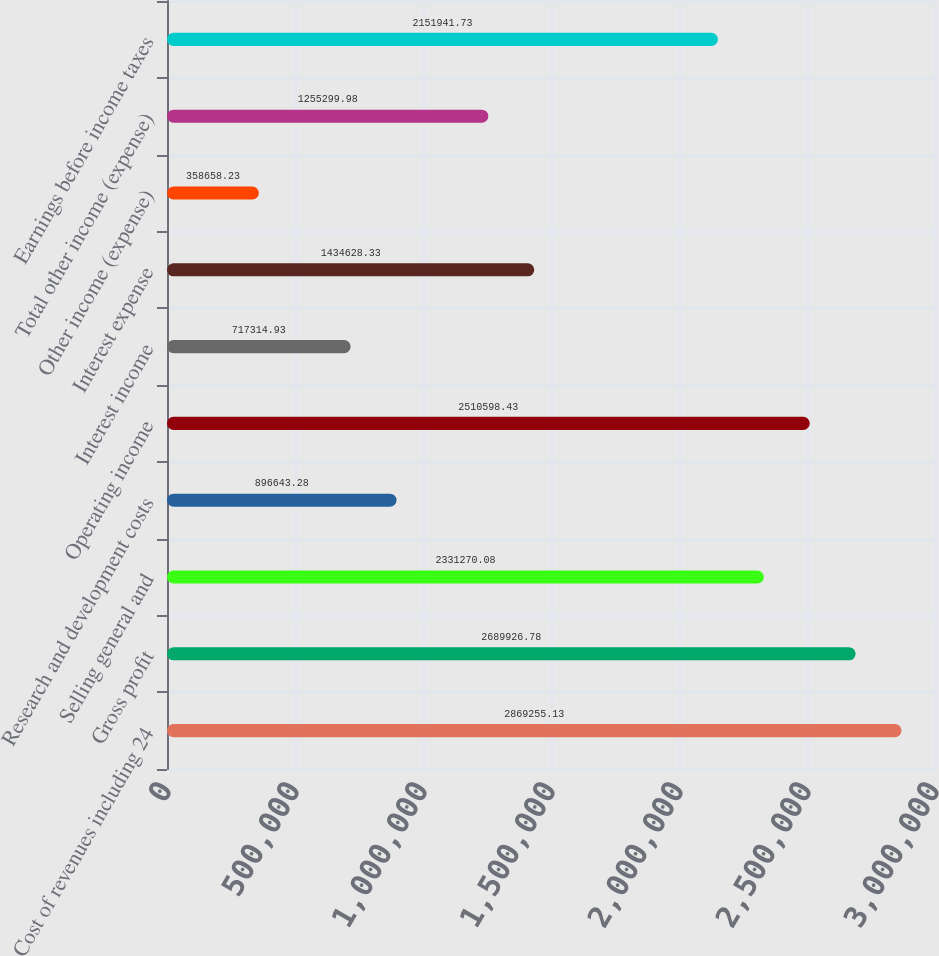Convert chart. <chart><loc_0><loc_0><loc_500><loc_500><bar_chart><fcel>Cost of revenues including 24<fcel>Gross profit<fcel>Selling general and<fcel>Research and development costs<fcel>Operating income<fcel>Interest income<fcel>Interest expense<fcel>Other income (expense)<fcel>Total other income (expense)<fcel>Earnings before income taxes<nl><fcel>2.86926e+06<fcel>2.68993e+06<fcel>2.33127e+06<fcel>896643<fcel>2.5106e+06<fcel>717315<fcel>1.43463e+06<fcel>358658<fcel>1.2553e+06<fcel>2.15194e+06<nl></chart> 